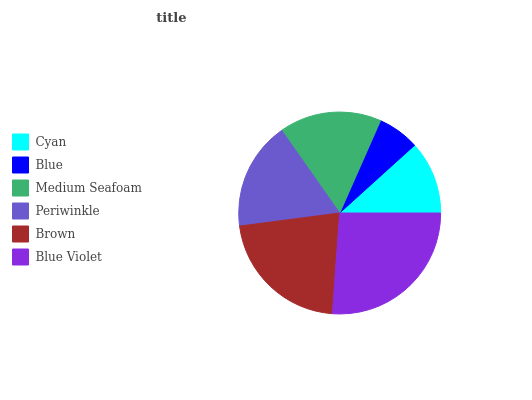Is Blue the minimum?
Answer yes or no. Yes. Is Blue Violet the maximum?
Answer yes or no. Yes. Is Medium Seafoam the minimum?
Answer yes or no. No. Is Medium Seafoam the maximum?
Answer yes or no. No. Is Medium Seafoam greater than Blue?
Answer yes or no. Yes. Is Blue less than Medium Seafoam?
Answer yes or no. Yes. Is Blue greater than Medium Seafoam?
Answer yes or no. No. Is Medium Seafoam less than Blue?
Answer yes or no. No. Is Periwinkle the high median?
Answer yes or no. Yes. Is Medium Seafoam the low median?
Answer yes or no. Yes. Is Medium Seafoam the high median?
Answer yes or no. No. Is Blue Violet the low median?
Answer yes or no. No. 